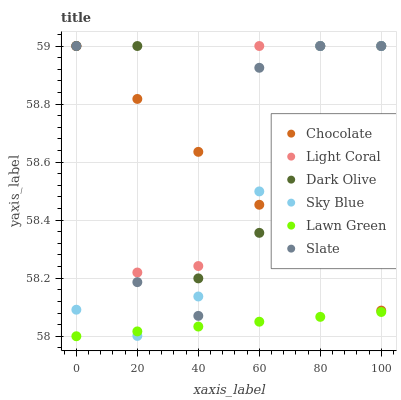Does Lawn Green have the minimum area under the curve?
Answer yes or no. Yes. Does Dark Olive have the maximum area under the curve?
Answer yes or no. Yes. Does Slate have the minimum area under the curve?
Answer yes or no. No. Does Slate have the maximum area under the curve?
Answer yes or no. No. Is Lawn Green the smoothest?
Answer yes or no. Yes. Is Dark Olive the roughest?
Answer yes or no. Yes. Is Slate the smoothest?
Answer yes or no. No. Is Slate the roughest?
Answer yes or no. No. Does Lawn Green have the lowest value?
Answer yes or no. Yes. Does Slate have the lowest value?
Answer yes or no. No. Does Sky Blue have the highest value?
Answer yes or no. Yes. Is Lawn Green less than Chocolate?
Answer yes or no. Yes. Is Chocolate greater than Lawn Green?
Answer yes or no. Yes. Does Sky Blue intersect Light Coral?
Answer yes or no. Yes. Is Sky Blue less than Light Coral?
Answer yes or no. No. Is Sky Blue greater than Light Coral?
Answer yes or no. No. Does Lawn Green intersect Chocolate?
Answer yes or no. No. 